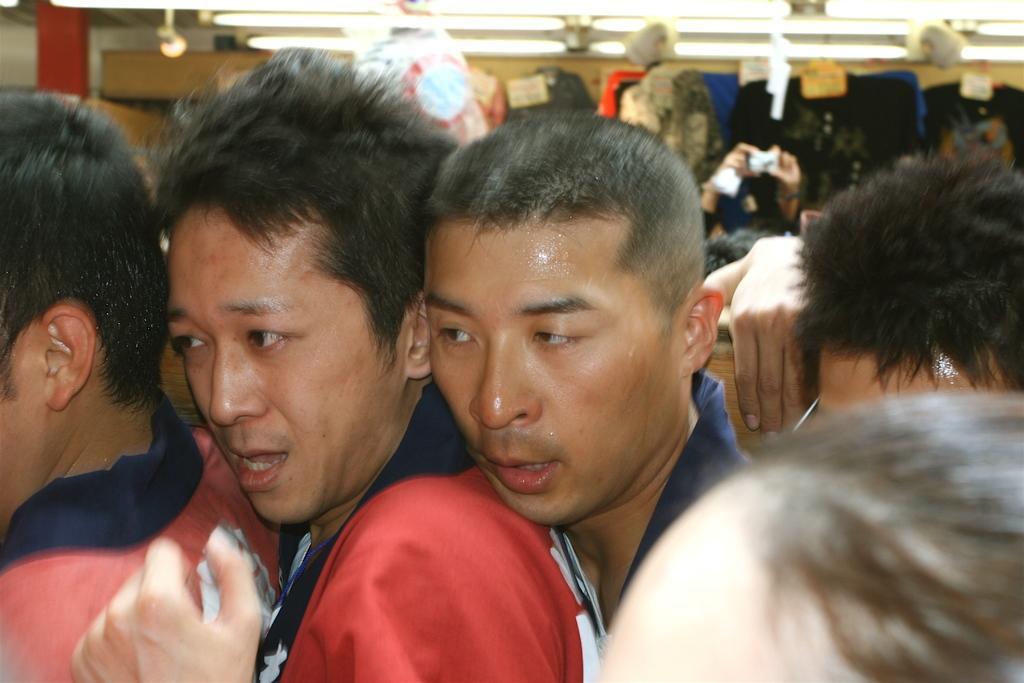In one or two sentences, can you explain what this image depicts? In this image there are people, lights and objects. In the background of the image it is blurry.  